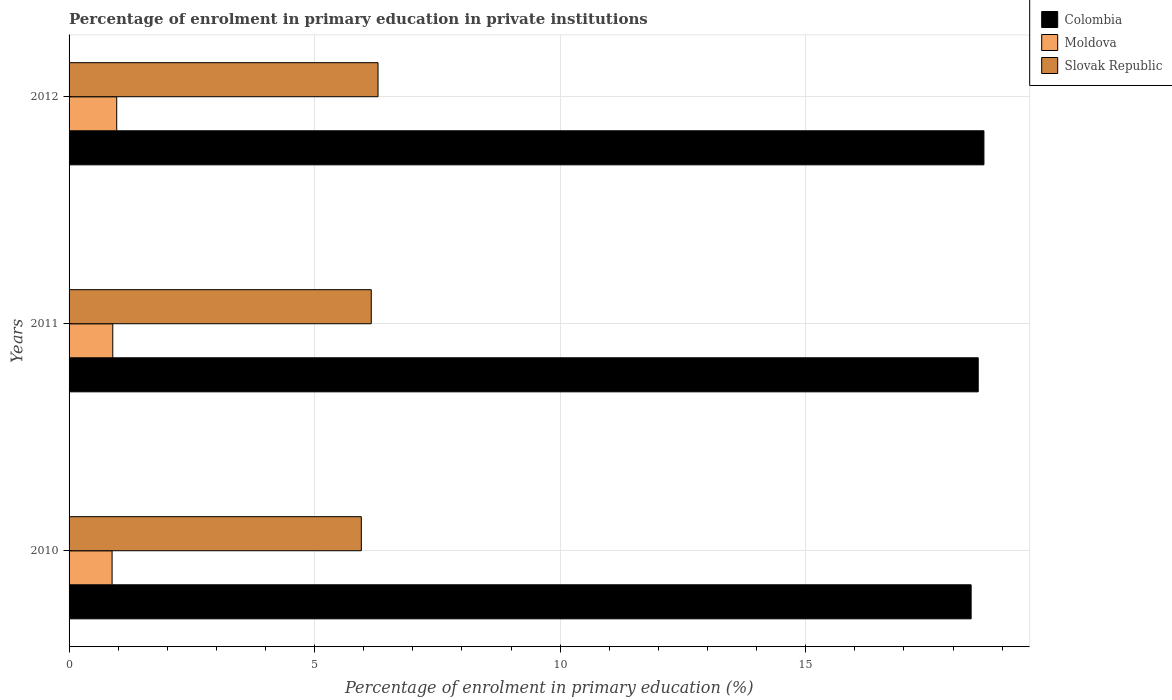How many different coloured bars are there?
Give a very brief answer. 3. How many bars are there on the 2nd tick from the bottom?
Ensure brevity in your answer.  3. What is the label of the 2nd group of bars from the top?
Give a very brief answer. 2011. In how many cases, is the number of bars for a given year not equal to the number of legend labels?
Offer a very short reply. 0. What is the percentage of enrolment in primary education in Colombia in 2010?
Provide a succinct answer. 18.37. Across all years, what is the maximum percentage of enrolment in primary education in Moldova?
Make the answer very short. 0.97. Across all years, what is the minimum percentage of enrolment in primary education in Moldova?
Your answer should be compact. 0.88. In which year was the percentage of enrolment in primary education in Colombia maximum?
Make the answer very short. 2012. What is the total percentage of enrolment in primary education in Moldova in the graph?
Offer a terse response. 2.74. What is the difference between the percentage of enrolment in primary education in Slovak Republic in 2010 and that in 2011?
Offer a terse response. -0.2. What is the difference between the percentage of enrolment in primary education in Colombia in 2011 and the percentage of enrolment in primary education in Slovak Republic in 2012?
Make the answer very short. 12.22. What is the average percentage of enrolment in primary education in Slovak Republic per year?
Ensure brevity in your answer.  6.13. In the year 2012, what is the difference between the percentage of enrolment in primary education in Slovak Republic and percentage of enrolment in primary education in Moldova?
Your answer should be very brief. 5.32. In how many years, is the percentage of enrolment in primary education in Slovak Republic greater than 9 %?
Provide a succinct answer. 0. What is the ratio of the percentage of enrolment in primary education in Colombia in 2011 to that in 2012?
Provide a short and direct response. 0.99. Is the difference between the percentage of enrolment in primary education in Slovak Republic in 2010 and 2011 greater than the difference between the percentage of enrolment in primary education in Moldova in 2010 and 2011?
Provide a short and direct response. No. What is the difference between the highest and the second highest percentage of enrolment in primary education in Colombia?
Provide a short and direct response. 0.12. What is the difference between the highest and the lowest percentage of enrolment in primary education in Colombia?
Make the answer very short. 0.26. What does the 2nd bar from the top in 2010 represents?
Give a very brief answer. Moldova. Is it the case that in every year, the sum of the percentage of enrolment in primary education in Colombia and percentage of enrolment in primary education in Moldova is greater than the percentage of enrolment in primary education in Slovak Republic?
Your answer should be very brief. Yes. How many bars are there?
Offer a very short reply. 9. Are all the bars in the graph horizontal?
Offer a very short reply. Yes. How many years are there in the graph?
Offer a terse response. 3. What is the difference between two consecutive major ticks on the X-axis?
Provide a succinct answer. 5. Does the graph contain any zero values?
Give a very brief answer. No. How many legend labels are there?
Offer a very short reply. 3. How are the legend labels stacked?
Provide a short and direct response. Vertical. What is the title of the graph?
Keep it short and to the point. Percentage of enrolment in primary education in private institutions. Does "Lower middle income" appear as one of the legend labels in the graph?
Your response must be concise. No. What is the label or title of the X-axis?
Your answer should be compact. Percentage of enrolment in primary education (%). What is the Percentage of enrolment in primary education (%) in Colombia in 2010?
Your answer should be very brief. 18.37. What is the Percentage of enrolment in primary education (%) in Moldova in 2010?
Keep it short and to the point. 0.88. What is the Percentage of enrolment in primary education (%) of Slovak Republic in 2010?
Provide a short and direct response. 5.95. What is the Percentage of enrolment in primary education (%) of Colombia in 2011?
Your answer should be very brief. 18.51. What is the Percentage of enrolment in primary education (%) in Moldova in 2011?
Your answer should be very brief. 0.89. What is the Percentage of enrolment in primary education (%) of Slovak Republic in 2011?
Offer a very short reply. 6.15. What is the Percentage of enrolment in primary education (%) in Colombia in 2012?
Ensure brevity in your answer.  18.63. What is the Percentage of enrolment in primary education (%) of Moldova in 2012?
Your answer should be compact. 0.97. What is the Percentage of enrolment in primary education (%) of Slovak Republic in 2012?
Offer a very short reply. 6.29. Across all years, what is the maximum Percentage of enrolment in primary education (%) in Colombia?
Your answer should be compact. 18.63. Across all years, what is the maximum Percentage of enrolment in primary education (%) in Moldova?
Keep it short and to the point. 0.97. Across all years, what is the maximum Percentage of enrolment in primary education (%) of Slovak Republic?
Keep it short and to the point. 6.29. Across all years, what is the minimum Percentage of enrolment in primary education (%) of Colombia?
Ensure brevity in your answer.  18.37. Across all years, what is the minimum Percentage of enrolment in primary education (%) of Moldova?
Your answer should be very brief. 0.88. Across all years, what is the minimum Percentage of enrolment in primary education (%) of Slovak Republic?
Keep it short and to the point. 5.95. What is the total Percentage of enrolment in primary education (%) of Colombia in the graph?
Keep it short and to the point. 55.51. What is the total Percentage of enrolment in primary education (%) in Moldova in the graph?
Your response must be concise. 2.74. What is the total Percentage of enrolment in primary education (%) in Slovak Republic in the graph?
Give a very brief answer. 18.4. What is the difference between the Percentage of enrolment in primary education (%) of Colombia in 2010 and that in 2011?
Your answer should be compact. -0.14. What is the difference between the Percentage of enrolment in primary education (%) of Moldova in 2010 and that in 2011?
Your answer should be very brief. -0.01. What is the difference between the Percentage of enrolment in primary education (%) in Slovak Republic in 2010 and that in 2011?
Give a very brief answer. -0.2. What is the difference between the Percentage of enrolment in primary education (%) of Colombia in 2010 and that in 2012?
Your response must be concise. -0.26. What is the difference between the Percentage of enrolment in primary education (%) in Moldova in 2010 and that in 2012?
Ensure brevity in your answer.  -0.09. What is the difference between the Percentage of enrolment in primary education (%) of Slovak Republic in 2010 and that in 2012?
Provide a short and direct response. -0.34. What is the difference between the Percentage of enrolment in primary education (%) in Colombia in 2011 and that in 2012?
Give a very brief answer. -0.12. What is the difference between the Percentage of enrolment in primary education (%) of Moldova in 2011 and that in 2012?
Give a very brief answer. -0.08. What is the difference between the Percentage of enrolment in primary education (%) of Slovak Republic in 2011 and that in 2012?
Make the answer very short. -0.14. What is the difference between the Percentage of enrolment in primary education (%) in Colombia in 2010 and the Percentage of enrolment in primary education (%) in Moldova in 2011?
Keep it short and to the point. 17.48. What is the difference between the Percentage of enrolment in primary education (%) in Colombia in 2010 and the Percentage of enrolment in primary education (%) in Slovak Republic in 2011?
Give a very brief answer. 12.21. What is the difference between the Percentage of enrolment in primary education (%) of Moldova in 2010 and the Percentage of enrolment in primary education (%) of Slovak Republic in 2011?
Your response must be concise. -5.28. What is the difference between the Percentage of enrolment in primary education (%) of Colombia in 2010 and the Percentage of enrolment in primary education (%) of Moldova in 2012?
Give a very brief answer. 17.4. What is the difference between the Percentage of enrolment in primary education (%) in Colombia in 2010 and the Percentage of enrolment in primary education (%) in Slovak Republic in 2012?
Your response must be concise. 12.08. What is the difference between the Percentage of enrolment in primary education (%) in Moldova in 2010 and the Percentage of enrolment in primary education (%) in Slovak Republic in 2012?
Provide a succinct answer. -5.42. What is the difference between the Percentage of enrolment in primary education (%) of Colombia in 2011 and the Percentage of enrolment in primary education (%) of Moldova in 2012?
Your answer should be compact. 17.54. What is the difference between the Percentage of enrolment in primary education (%) in Colombia in 2011 and the Percentage of enrolment in primary education (%) in Slovak Republic in 2012?
Make the answer very short. 12.22. What is the difference between the Percentage of enrolment in primary education (%) in Moldova in 2011 and the Percentage of enrolment in primary education (%) in Slovak Republic in 2012?
Your response must be concise. -5.4. What is the average Percentage of enrolment in primary education (%) in Colombia per year?
Your response must be concise. 18.5. What is the average Percentage of enrolment in primary education (%) of Moldova per year?
Offer a very short reply. 0.91. What is the average Percentage of enrolment in primary education (%) of Slovak Republic per year?
Keep it short and to the point. 6.13. In the year 2010, what is the difference between the Percentage of enrolment in primary education (%) in Colombia and Percentage of enrolment in primary education (%) in Moldova?
Provide a short and direct response. 17.49. In the year 2010, what is the difference between the Percentage of enrolment in primary education (%) in Colombia and Percentage of enrolment in primary education (%) in Slovak Republic?
Give a very brief answer. 12.42. In the year 2010, what is the difference between the Percentage of enrolment in primary education (%) of Moldova and Percentage of enrolment in primary education (%) of Slovak Republic?
Your answer should be very brief. -5.07. In the year 2011, what is the difference between the Percentage of enrolment in primary education (%) in Colombia and Percentage of enrolment in primary education (%) in Moldova?
Your answer should be very brief. 17.62. In the year 2011, what is the difference between the Percentage of enrolment in primary education (%) in Colombia and Percentage of enrolment in primary education (%) in Slovak Republic?
Ensure brevity in your answer.  12.36. In the year 2011, what is the difference between the Percentage of enrolment in primary education (%) of Moldova and Percentage of enrolment in primary education (%) of Slovak Republic?
Your response must be concise. -5.26. In the year 2012, what is the difference between the Percentage of enrolment in primary education (%) of Colombia and Percentage of enrolment in primary education (%) of Moldova?
Provide a short and direct response. 17.66. In the year 2012, what is the difference between the Percentage of enrolment in primary education (%) in Colombia and Percentage of enrolment in primary education (%) in Slovak Republic?
Offer a terse response. 12.34. In the year 2012, what is the difference between the Percentage of enrolment in primary education (%) of Moldova and Percentage of enrolment in primary education (%) of Slovak Republic?
Offer a terse response. -5.32. What is the ratio of the Percentage of enrolment in primary education (%) in Colombia in 2010 to that in 2011?
Provide a short and direct response. 0.99. What is the ratio of the Percentage of enrolment in primary education (%) in Moldova in 2010 to that in 2011?
Offer a terse response. 0.98. What is the ratio of the Percentage of enrolment in primary education (%) in Slovak Republic in 2010 to that in 2011?
Provide a short and direct response. 0.97. What is the ratio of the Percentage of enrolment in primary education (%) in Colombia in 2010 to that in 2012?
Ensure brevity in your answer.  0.99. What is the ratio of the Percentage of enrolment in primary education (%) of Moldova in 2010 to that in 2012?
Your response must be concise. 0.9. What is the ratio of the Percentage of enrolment in primary education (%) of Slovak Republic in 2010 to that in 2012?
Your answer should be compact. 0.95. What is the ratio of the Percentage of enrolment in primary education (%) in Colombia in 2011 to that in 2012?
Offer a terse response. 0.99. What is the ratio of the Percentage of enrolment in primary education (%) in Moldova in 2011 to that in 2012?
Provide a short and direct response. 0.92. What is the ratio of the Percentage of enrolment in primary education (%) in Slovak Republic in 2011 to that in 2012?
Provide a succinct answer. 0.98. What is the difference between the highest and the second highest Percentage of enrolment in primary education (%) in Colombia?
Keep it short and to the point. 0.12. What is the difference between the highest and the second highest Percentage of enrolment in primary education (%) in Moldova?
Offer a terse response. 0.08. What is the difference between the highest and the second highest Percentage of enrolment in primary education (%) in Slovak Republic?
Give a very brief answer. 0.14. What is the difference between the highest and the lowest Percentage of enrolment in primary education (%) of Colombia?
Your answer should be very brief. 0.26. What is the difference between the highest and the lowest Percentage of enrolment in primary education (%) in Moldova?
Make the answer very short. 0.09. What is the difference between the highest and the lowest Percentage of enrolment in primary education (%) in Slovak Republic?
Provide a succinct answer. 0.34. 